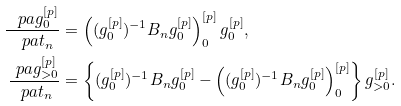Convert formula to latex. <formula><loc_0><loc_0><loc_500><loc_500>\frac { \ p a g ^ { [ p ] } _ { 0 } } { \ p a t _ { n } } & = \left ( ( g ^ { [ p ] } _ { 0 } ) ^ { - 1 } B _ { n } g ^ { [ p ] } _ { 0 } \right ) ^ { [ p ] } _ { 0 } g ^ { [ p ] } _ { 0 } , \\ \frac { \ p a g ^ { [ p ] } _ { > 0 } } { \ p a t _ { n } } & = \left \{ ( g ^ { [ p ] } _ { 0 } ) ^ { - 1 } B _ { n } g ^ { [ p ] } _ { 0 } - \left ( ( g ^ { [ p ] } _ { 0 } ) ^ { - 1 } B _ { n } g ^ { [ p ] } _ { 0 } \right ) ^ { [ p ] } _ { 0 } \right \} g ^ { [ p ] } _ { > 0 } .</formula> 